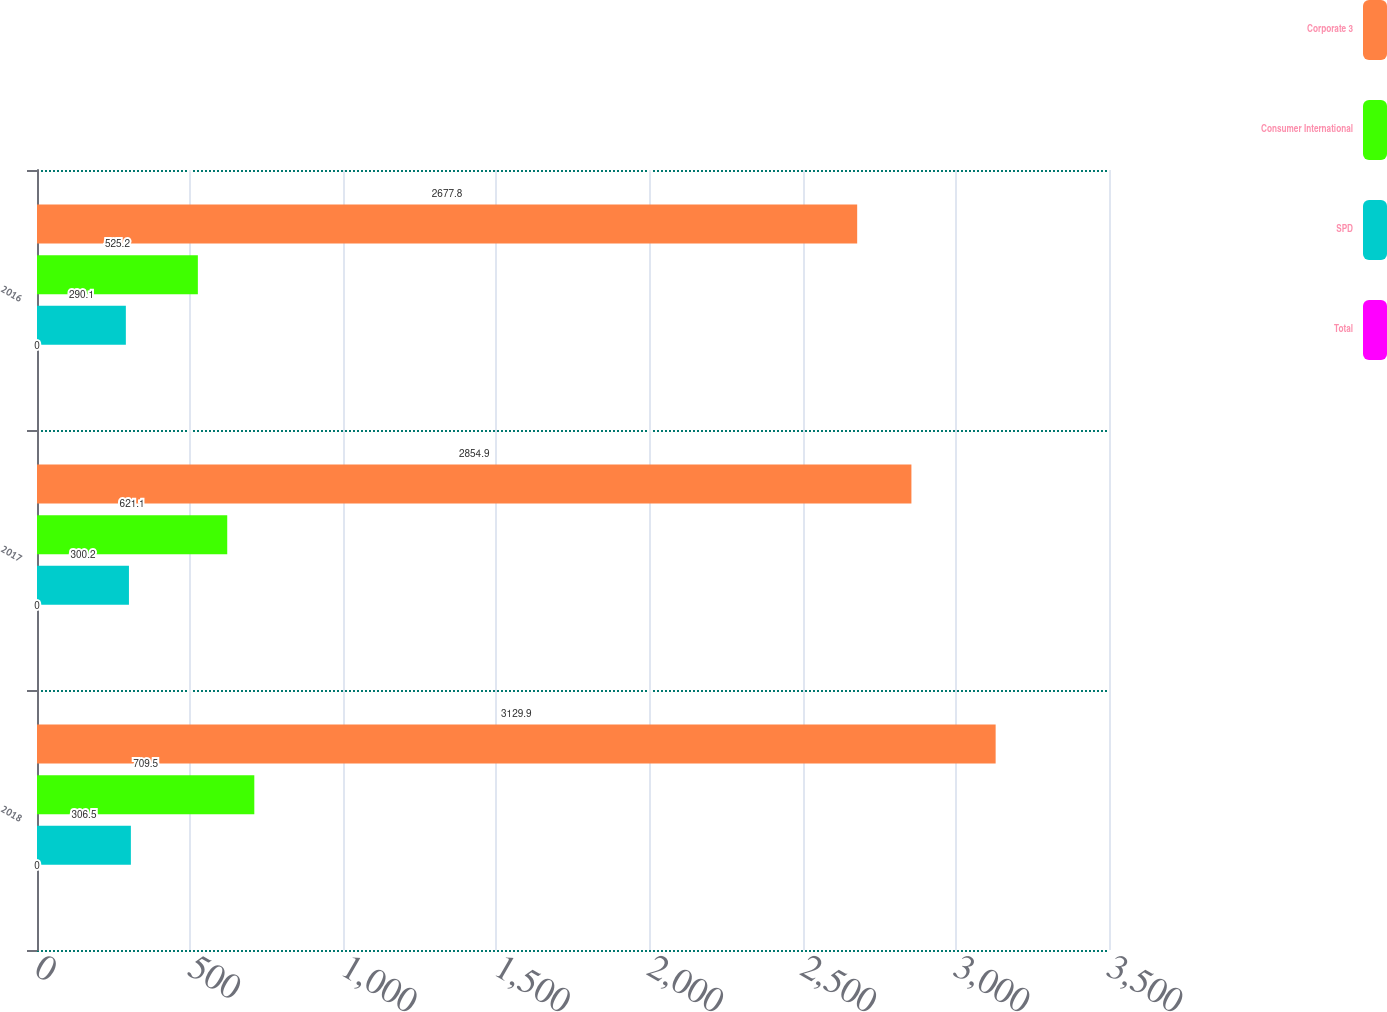Convert chart. <chart><loc_0><loc_0><loc_500><loc_500><stacked_bar_chart><ecel><fcel>2018<fcel>2017<fcel>2016<nl><fcel>Corporate 3<fcel>3129.9<fcel>2854.9<fcel>2677.8<nl><fcel>Consumer International<fcel>709.5<fcel>621.1<fcel>525.2<nl><fcel>SPD<fcel>306.5<fcel>300.2<fcel>290.1<nl><fcel>Total<fcel>0<fcel>0<fcel>0<nl></chart> 